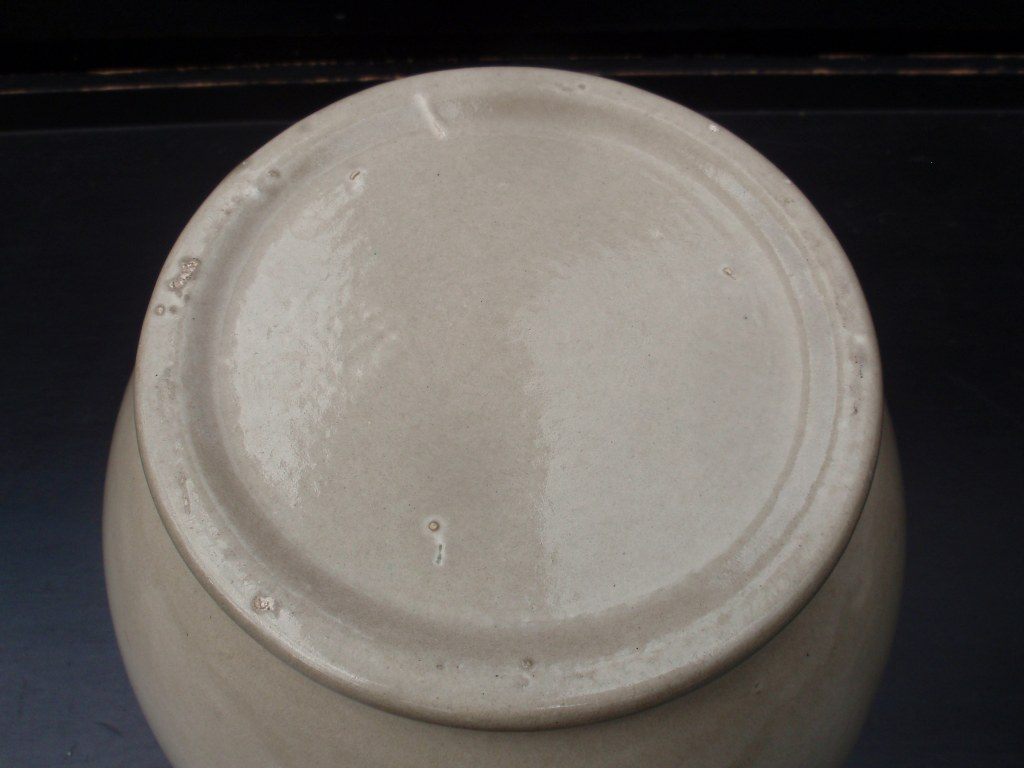What might be the historical significance of an object like this? Historically, an object like this pot could have been used for daily activities such as cooking or storage, but it might also have played a role in cultural rituals or practices. In many ancient civilizations, pottery items were often decorated and personalized, indicating their importance in households and ceremonies. This pot, with its minimalistic design, suggests a functional role, possibly in an average household's kitchen. Yet, its well-crafted form hints at a skilled artisan's touch, indicating its value in historical daily life. 